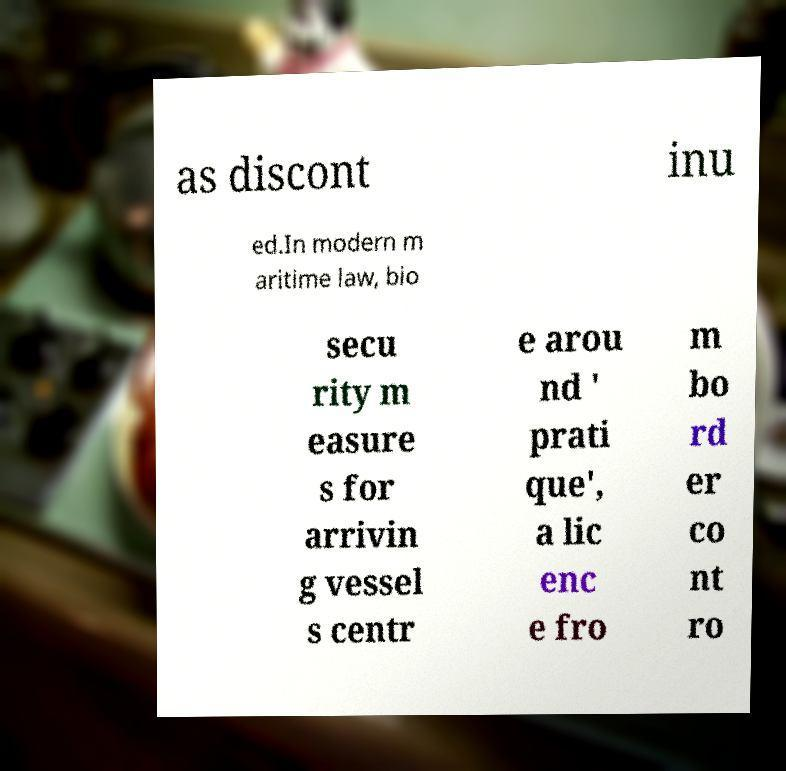Could you assist in decoding the text presented in this image and type it out clearly? as discont inu ed.In modern m aritime law, bio secu rity m easure s for arrivin g vessel s centr e arou nd ' prati que', a lic enc e fro m bo rd er co nt ro 